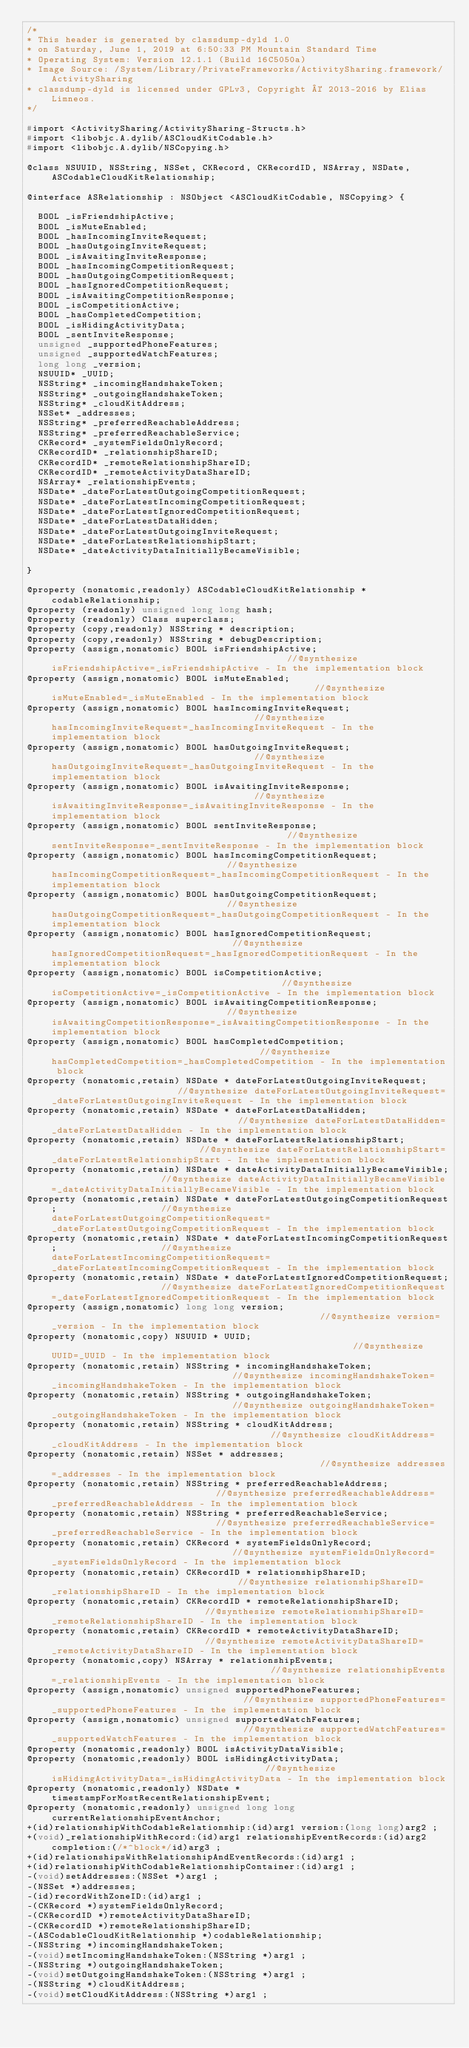Convert code to text. <code><loc_0><loc_0><loc_500><loc_500><_C_>/*
* This header is generated by classdump-dyld 1.0
* on Saturday, June 1, 2019 at 6:50:33 PM Mountain Standard Time
* Operating System: Version 12.1.1 (Build 16C5050a)
* Image Source: /System/Library/PrivateFrameworks/ActivitySharing.framework/ActivitySharing
* classdump-dyld is licensed under GPLv3, Copyright © 2013-2016 by Elias Limneos.
*/

#import <ActivitySharing/ActivitySharing-Structs.h>
#import <libobjc.A.dylib/ASCloudKitCodable.h>
#import <libobjc.A.dylib/NSCopying.h>

@class NSUUID, NSString, NSSet, CKRecord, CKRecordID, NSArray, NSDate, ASCodableCloudKitRelationship;

@interface ASRelationship : NSObject <ASCloudKitCodable, NSCopying> {

	BOOL _isFriendshipActive;
	BOOL _isMuteEnabled;
	BOOL _hasIncomingInviteRequest;
	BOOL _hasOutgoingInviteRequest;
	BOOL _isAwaitingInviteResponse;
	BOOL _hasIncomingCompetitionRequest;
	BOOL _hasOutgoingCompetitionRequest;
	BOOL _hasIgnoredCompetitionRequest;
	BOOL _isAwaitingCompetitionResponse;
	BOOL _isCompetitionActive;
	BOOL _hasCompletedCompetition;
	BOOL _isHidingActivityData;
	BOOL _sentInviteResponse;
	unsigned _supportedPhoneFeatures;
	unsigned _supportedWatchFeatures;
	long long _version;
	NSUUID* _UUID;
	NSString* _incomingHandshakeToken;
	NSString* _outgoingHandshakeToken;
	NSString* _cloudKitAddress;
	NSSet* _addresses;
	NSString* _preferredReachableAddress;
	NSString* _preferredReachableService;
	CKRecord* _systemFieldsOnlyRecord;
	CKRecordID* _relationshipShareID;
	CKRecordID* _remoteRelationshipShareID;
	CKRecordID* _remoteActivityDataShareID;
	NSArray* _relationshipEvents;
	NSDate* _dateForLatestOutgoingCompetitionRequest;
	NSDate* _dateForLatestIncomingCompetitionRequest;
	NSDate* _dateForLatestIgnoredCompetitionRequest;
	NSDate* _dateForLatestDataHidden;
	NSDate* _dateForLatestOutgoingInviteRequest;
	NSDate* _dateForLatestRelationshipStart;
	NSDate* _dateActivityDataInitiallyBecameVisible;

}

@property (nonatomic,readonly) ASCodableCloudKitRelationship * codableRelationship; 
@property (readonly) unsigned long long hash; 
@property (readonly) Class superclass; 
@property (copy,readonly) NSString * description; 
@property (copy,readonly) NSString * debugDescription; 
@property (assign,nonatomic) BOOL isFriendshipActive;                                            //@synthesize isFriendshipActive=_isFriendshipActive - In the implementation block
@property (assign,nonatomic) BOOL isMuteEnabled;                                                 //@synthesize isMuteEnabled=_isMuteEnabled - In the implementation block
@property (assign,nonatomic) BOOL hasIncomingInviteRequest;                                      //@synthesize hasIncomingInviteRequest=_hasIncomingInviteRequest - In the implementation block
@property (assign,nonatomic) BOOL hasOutgoingInviteRequest;                                      //@synthesize hasOutgoingInviteRequest=_hasOutgoingInviteRequest - In the implementation block
@property (assign,nonatomic) BOOL isAwaitingInviteResponse;                                      //@synthesize isAwaitingInviteResponse=_isAwaitingInviteResponse - In the implementation block
@property (assign,nonatomic) BOOL sentInviteResponse;                                            //@synthesize sentInviteResponse=_sentInviteResponse - In the implementation block
@property (assign,nonatomic) BOOL hasIncomingCompetitionRequest;                                 //@synthesize hasIncomingCompetitionRequest=_hasIncomingCompetitionRequest - In the implementation block
@property (assign,nonatomic) BOOL hasOutgoingCompetitionRequest;                                 //@synthesize hasOutgoingCompetitionRequest=_hasOutgoingCompetitionRequest - In the implementation block
@property (assign,nonatomic) BOOL hasIgnoredCompetitionRequest;                                  //@synthesize hasIgnoredCompetitionRequest=_hasIgnoredCompetitionRequest - In the implementation block
@property (assign,nonatomic) BOOL isCompetitionActive;                                           //@synthesize isCompetitionActive=_isCompetitionActive - In the implementation block
@property (assign,nonatomic) BOOL isAwaitingCompetitionResponse;                                 //@synthesize isAwaitingCompetitionResponse=_isAwaitingCompetitionResponse - In the implementation block
@property (assign,nonatomic) BOOL hasCompletedCompetition;                                       //@synthesize hasCompletedCompetition=_hasCompletedCompetition - In the implementation block
@property (nonatomic,retain) NSDate * dateForLatestOutgoingInviteRequest;                        //@synthesize dateForLatestOutgoingInviteRequest=_dateForLatestOutgoingInviteRequest - In the implementation block
@property (nonatomic,retain) NSDate * dateForLatestDataHidden;                                   //@synthesize dateForLatestDataHidden=_dateForLatestDataHidden - In the implementation block
@property (nonatomic,retain) NSDate * dateForLatestRelationshipStart;                            //@synthesize dateForLatestRelationshipStart=_dateForLatestRelationshipStart - In the implementation block
@property (nonatomic,retain) NSDate * dateActivityDataInitiallyBecameVisible;                    //@synthesize dateActivityDataInitiallyBecameVisible=_dateActivityDataInitiallyBecameVisible - In the implementation block
@property (nonatomic,retain) NSDate * dateForLatestOutgoingCompetitionRequest;                   //@synthesize dateForLatestOutgoingCompetitionRequest=_dateForLatestOutgoingCompetitionRequest - In the implementation block
@property (nonatomic,retain) NSDate * dateForLatestIncomingCompetitionRequest;                   //@synthesize dateForLatestIncomingCompetitionRequest=_dateForLatestIncomingCompetitionRequest - In the implementation block
@property (nonatomic,retain) NSDate * dateForLatestIgnoredCompetitionRequest;                    //@synthesize dateForLatestIgnoredCompetitionRequest=_dateForLatestIgnoredCompetitionRequest - In the implementation block
@property (assign,nonatomic) long long version;                                                  //@synthesize version=_version - In the implementation block
@property (nonatomic,copy) NSUUID * UUID;                                                        //@synthesize UUID=_UUID - In the implementation block
@property (nonatomic,retain) NSString * incomingHandshakeToken;                                  //@synthesize incomingHandshakeToken=_incomingHandshakeToken - In the implementation block
@property (nonatomic,retain) NSString * outgoingHandshakeToken;                                  //@synthesize outgoingHandshakeToken=_outgoingHandshakeToken - In the implementation block
@property (nonatomic,retain) NSString * cloudKitAddress;                                         //@synthesize cloudKitAddress=_cloudKitAddress - In the implementation block
@property (nonatomic,retain) NSSet * addresses;                                                  //@synthesize addresses=_addresses - In the implementation block
@property (nonatomic,retain) NSString * preferredReachableAddress;                               //@synthesize preferredReachableAddress=_preferredReachableAddress - In the implementation block
@property (nonatomic,retain) NSString * preferredReachableService;                               //@synthesize preferredReachableService=_preferredReachableService - In the implementation block
@property (nonatomic,retain) CKRecord * systemFieldsOnlyRecord;                                  //@synthesize systemFieldsOnlyRecord=_systemFieldsOnlyRecord - In the implementation block
@property (nonatomic,retain) CKRecordID * relationshipShareID;                                   //@synthesize relationshipShareID=_relationshipShareID - In the implementation block
@property (nonatomic,retain) CKRecordID * remoteRelationshipShareID;                             //@synthesize remoteRelationshipShareID=_remoteRelationshipShareID - In the implementation block
@property (nonatomic,retain) CKRecordID * remoteActivityDataShareID;                             //@synthesize remoteActivityDataShareID=_remoteActivityDataShareID - In the implementation block
@property (nonatomic,copy) NSArray * relationshipEvents;                                         //@synthesize relationshipEvents=_relationshipEvents - In the implementation block
@property (assign,nonatomic) unsigned supportedPhoneFeatures;                                    //@synthesize supportedPhoneFeatures=_supportedPhoneFeatures - In the implementation block
@property (assign,nonatomic) unsigned supportedWatchFeatures;                                    //@synthesize supportedWatchFeatures=_supportedWatchFeatures - In the implementation block
@property (nonatomic,readonly) BOOL isActivityDataVisible; 
@property (nonatomic,readonly) BOOL isHidingActivityData;                                        //@synthesize isHidingActivityData=_isHidingActivityData - In the implementation block
@property (nonatomic,readonly) NSDate * timestampForMostRecentRelationshipEvent; 
@property (nonatomic,readonly) unsigned long long currentRelationshipEventAnchor; 
+(id)relationshipWithCodableRelationship:(id)arg1 version:(long long)arg2 ;
+(void)_relationshipWithRecord:(id)arg1 relationshipEventRecords:(id)arg2 completion:(/*^block*/id)arg3 ;
+(id)relationshipsWithRelationshipAndEventRecords:(id)arg1 ;
+(id)relationshipWithCodableRelationshipContainer:(id)arg1 ;
-(void)setAddresses:(NSSet *)arg1 ;
-(NSSet *)addresses;
-(id)recordWithZoneID:(id)arg1 ;
-(CKRecord *)systemFieldsOnlyRecord;
-(CKRecordID *)remoteActivityDataShareID;
-(CKRecordID *)remoteRelationshipShareID;
-(ASCodableCloudKitRelationship *)codableRelationship;
-(NSString *)incomingHandshakeToken;
-(void)setIncomingHandshakeToken:(NSString *)arg1 ;
-(NSString *)outgoingHandshakeToken;
-(void)setOutgoingHandshakeToken:(NSString *)arg1 ;
-(NSString *)cloudKitAddress;
-(void)setCloudKitAddress:(NSString *)arg1 ;</code> 